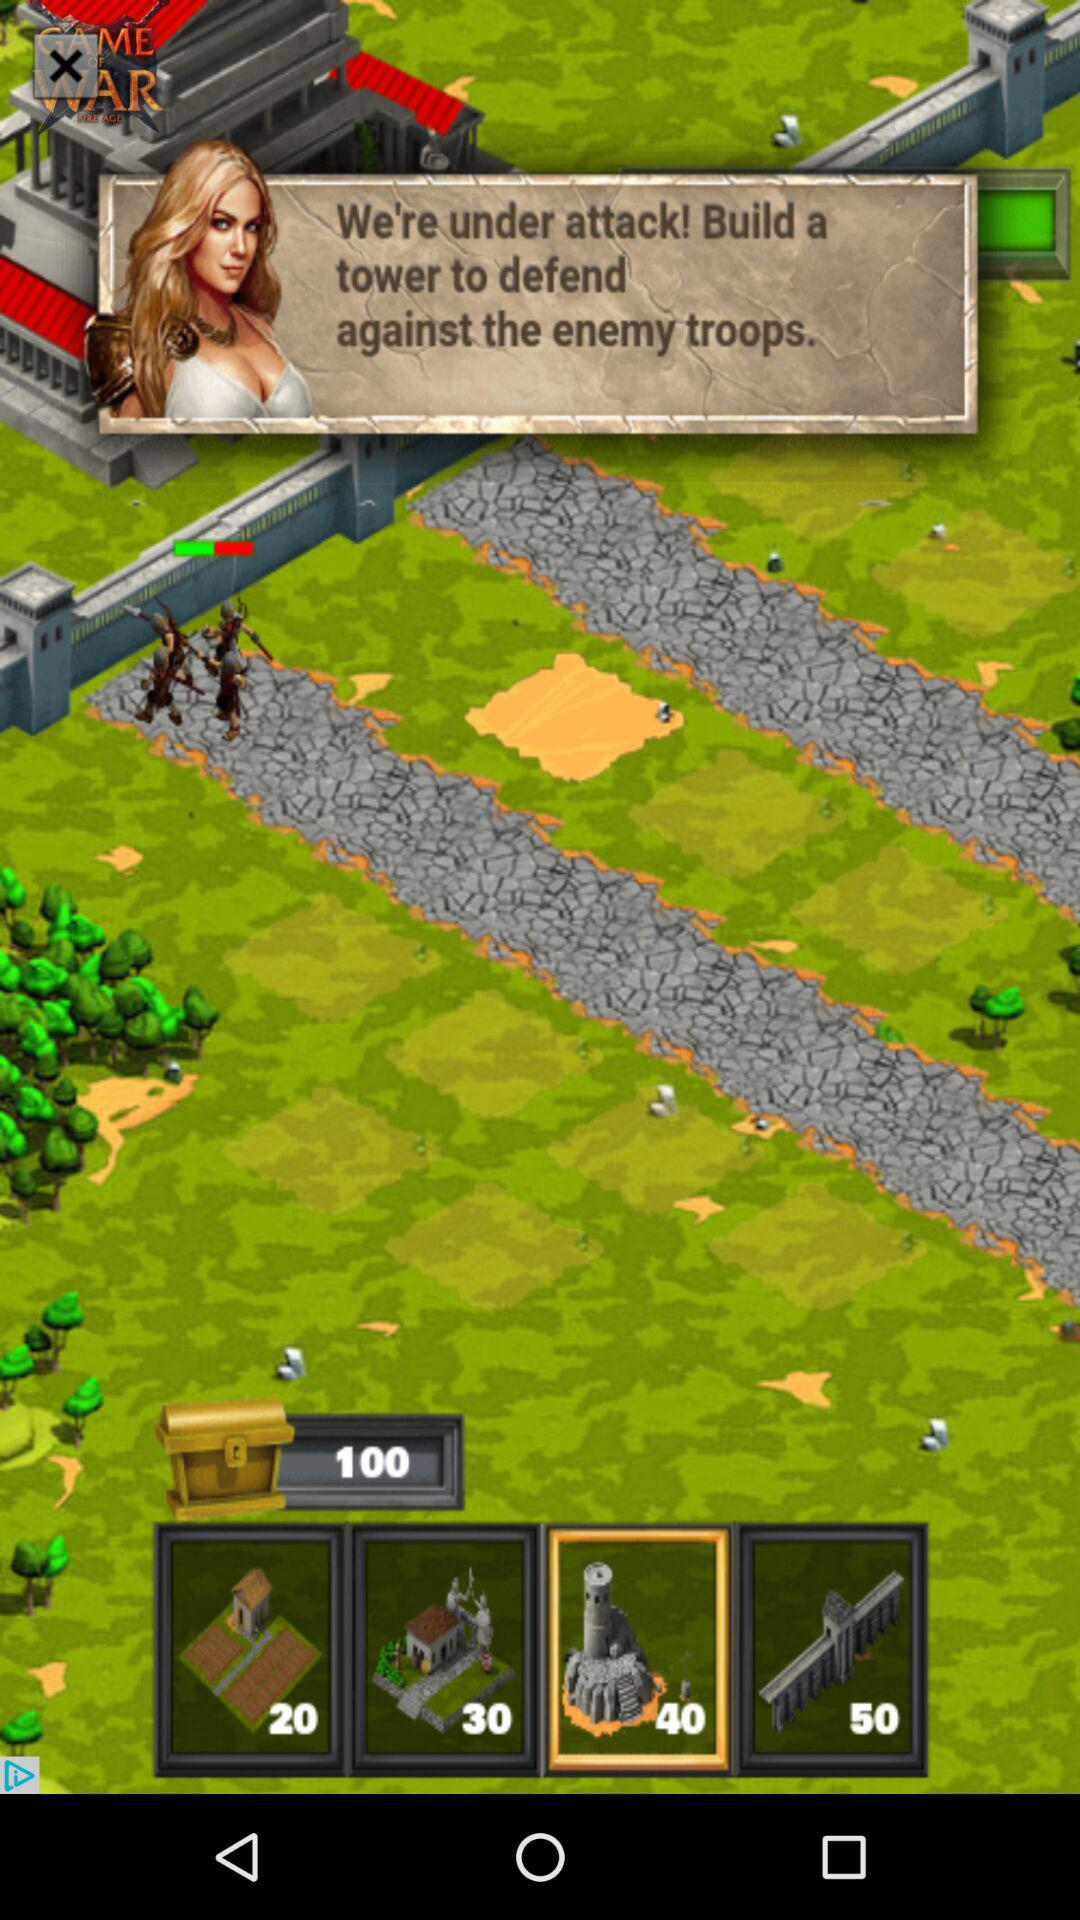What is the name of the game? The name of the game is "Game War". 